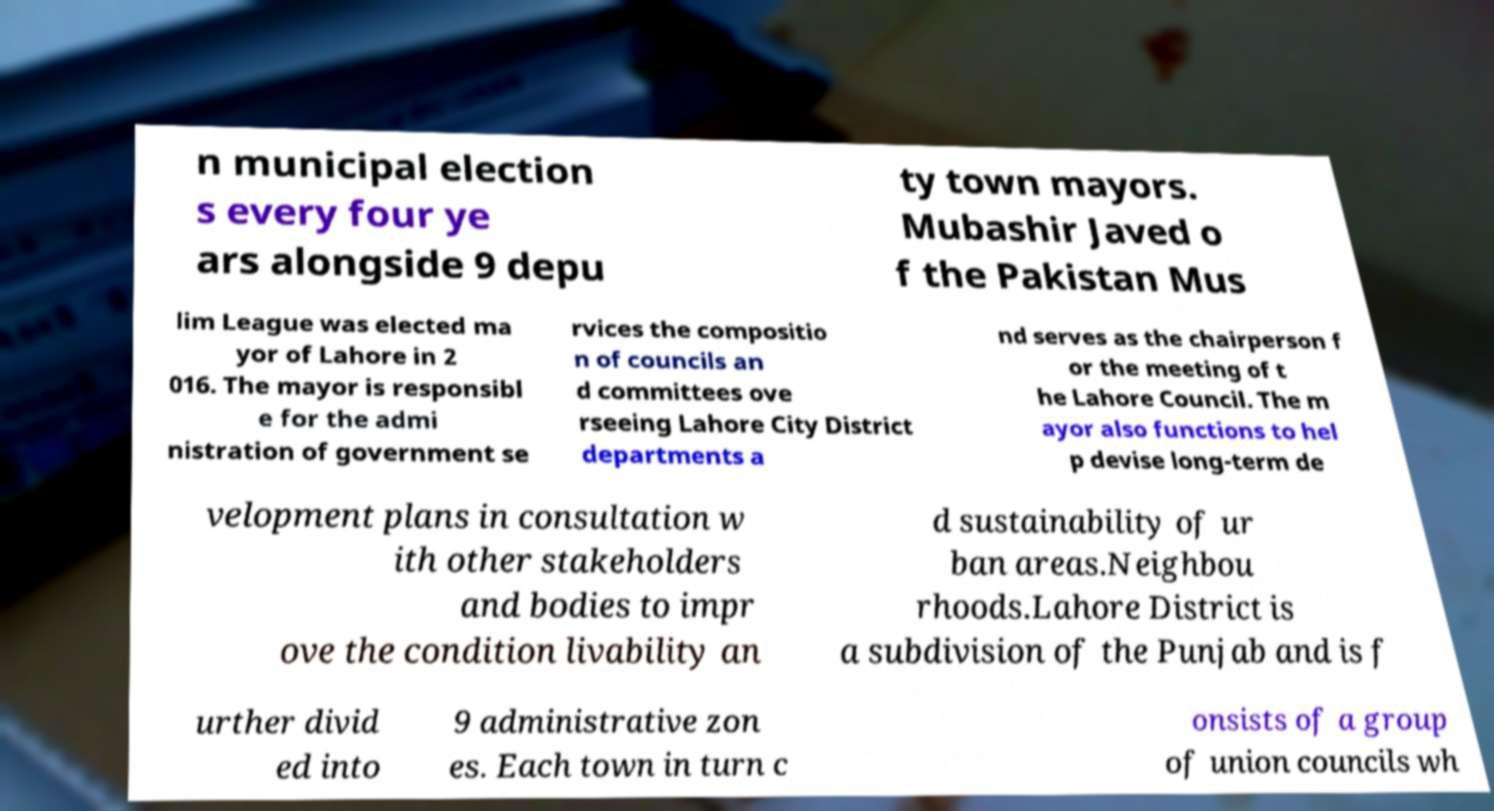For documentation purposes, I need the text within this image transcribed. Could you provide that? n municipal election s every four ye ars alongside 9 depu ty town mayors. Mubashir Javed o f the Pakistan Mus lim League was elected ma yor of Lahore in 2 016. The mayor is responsibl e for the admi nistration of government se rvices the compositio n of councils an d committees ove rseeing Lahore City District departments a nd serves as the chairperson f or the meeting of t he Lahore Council. The m ayor also functions to hel p devise long-term de velopment plans in consultation w ith other stakeholders and bodies to impr ove the condition livability an d sustainability of ur ban areas.Neighbou rhoods.Lahore District is a subdivision of the Punjab and is f urther divid ed into 9 administrative zon es. Each town in turn c onsists of a group of union councils wh 